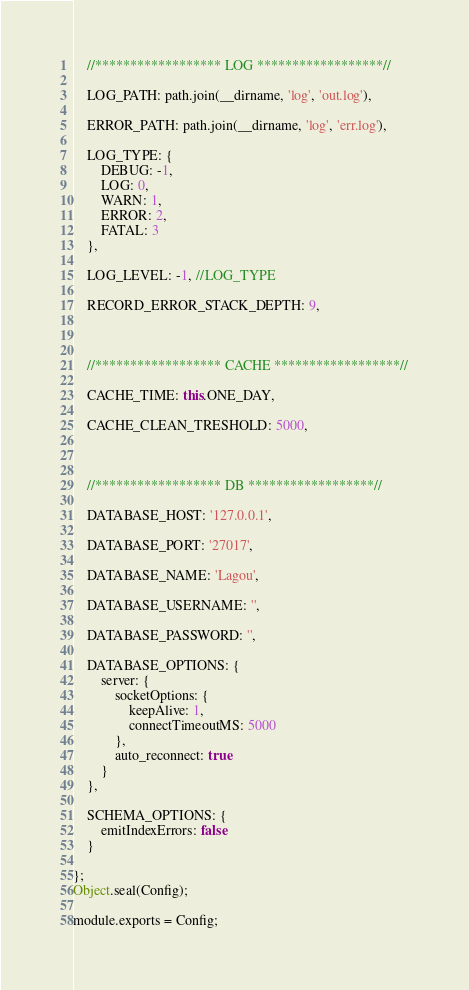<code> <loc_0><loc_0><loc_500><loc_500><_JavaScript_>


    //****************** LOG ******************//

    LOG_PATH: path.join(__dirname, 'log', 'out.log'),

    ERROR_PATH: path.join(__dirname, 'log', 'err.log'),

    LOG_TYPE: {
        DEBUG: -1,
        LOG: 0,
        WARN: 1,
        ERROR: 2,
        FATAL: 3
    },

    LOG_LEVEL: -1, //LOG_TYPE

    RECORD_ERROR_STACK_DEPTH: 9,



    //****************** CACHE ******************//

    CACHE_TIME: this.ONE_DAY,

    CACHE_CLEAN_TRESHOLD: 5000,



    //****************** DB ******************//

    DATABASE_HOST: '127.0.0.1',

    DATABASE_PORT: '27017',

    DATABASE_NAME: 'Lagou',

    DATABASE_USERNAME: '',

    DATABASE_PASSWORD: '',

    DATABASE_OPTIONS: {
        server: {
            socketOptions: {
                keepAlive: 1,
                connectTimeoutMS: 5000
            },
            auto_reconnect: true
        }
    },

    SCHEMA_OPTIONS: {
        emitIndexErrors: false
    }

};
Object.seal(Config);

module.exports = Config;
</code> 